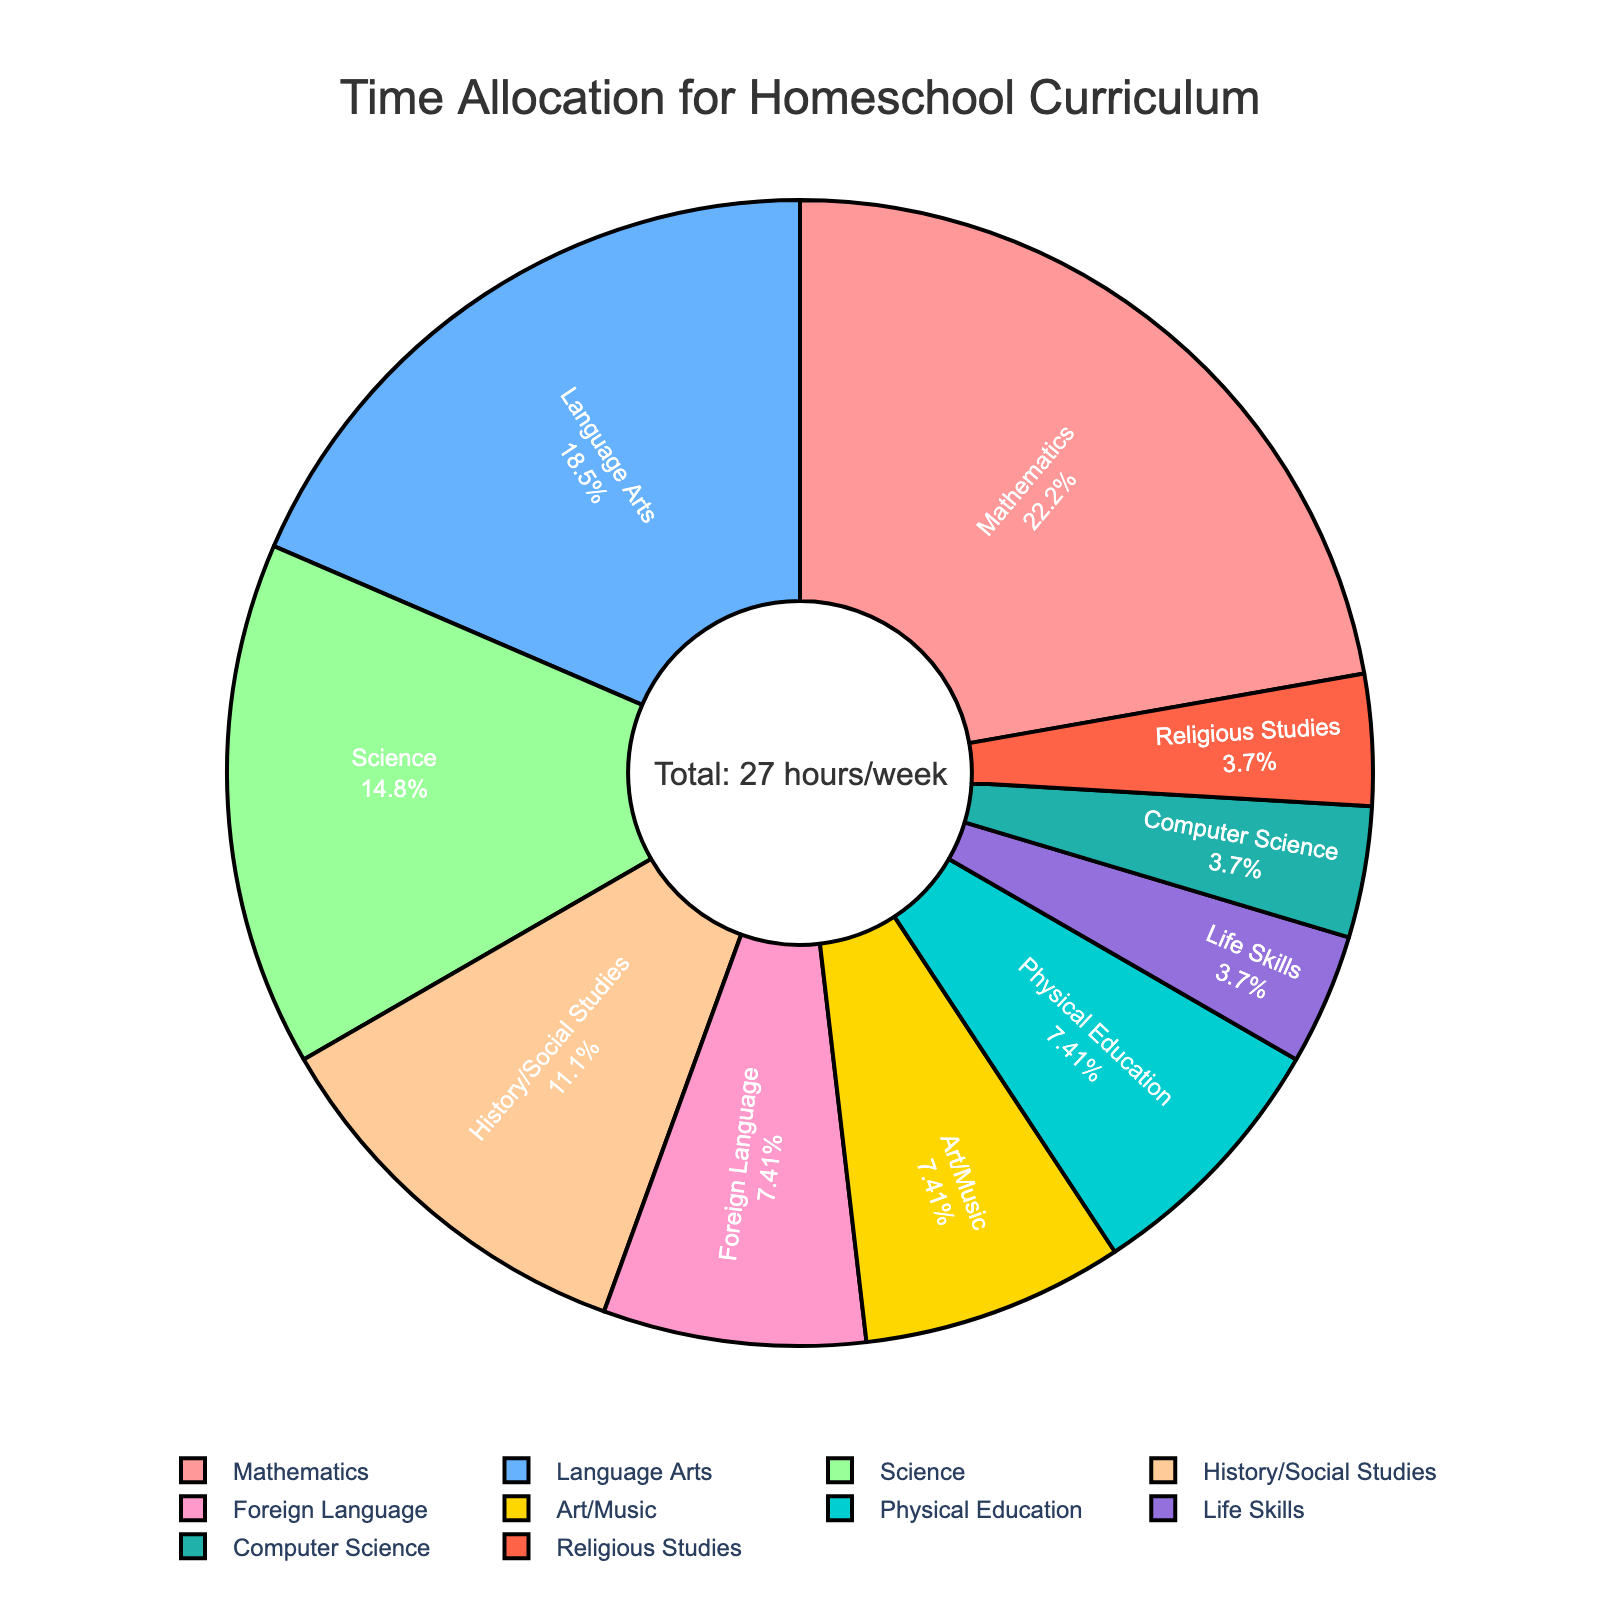What's the largest subject in terms of time allocation? The pie chart shows clear labeling of each subject along with their percentage. The largest segment is marked for Mathematics, with the highest percentage.
Answer: Mathematics What's the total time allocated to subjects other than Mathematics? First, identify the hours for each subject from the provided data. Then, subtract the hours allocated to Mathematics (6 hours) from the total hours (27 hours). So, 27 - 6 = 21 hours are allocated to other subjects.
Answer: 21 hours Which subject shares the same amount of weekly hours as Art/Music? The pie chart shows the percentage and the name of each subject. Art/Music and Physical Education both have the same time allocation.
Answer: Physical Education How much more time is spent on Mathematics compared to Foreign Language? The hours for each subject are provided. Subtract the hours spent on Foreign Language (2 hours) from those on Mathematics (6 hours), resulting in 6 - 2 = 4 hours.
Answer: 4 hours What percentage of time is allocated to Science? The percentage for each subject is shown on the pie chart. Science is labeled with its corresponding percentage (14.81%).
Answer: 14.81% Which subjects are allocated the least amount of weekly hours? The pie chart segments show the labels and percentages for each subject. Life Skills, Computer Science, and Religious Studies are each allocated 1 hour, which is the least.
Answer: Life Skills, Computer Science, Religious Studies How does the time allocation for Language Arts compare to that for Science? The pie chart segments labeled Language Arts and Science show their percentages. Language Arts has 18.52%, while Science has 14.81%.
Answer: Language Arts has a higher allocation What fraction of the total time is spent on Arts/Music, Physical Education, and Life Skills combined? Add the hours for Art/Music (2), Physical Education (2), and Life Skills (1). The total is 2 + 2 + 1 = 5 hours. The fraction is 5 hours out of 27 total hours.
Answer: 5/27 What is the percentage difference between the time spent on History/Social Studies and Mathematics? The pie chart provides the percentages for History/Social Studies (11.11%) and Mathematics (22.22%). Subtract the smaller percentage from the larger percentage to get the difference: 22.22% - 11.11% = 11.11%.
Answer: 11.11% How much more time in percentage is allocated to Science than Foreign Language? Find the percentages for Science (14.81%) and Foreign Language (7.41%). Subtract the smaller percentage from the larger percentage to get the difference: 14.81% - 7.41% = 7.41%.
Answer: 7.41% 